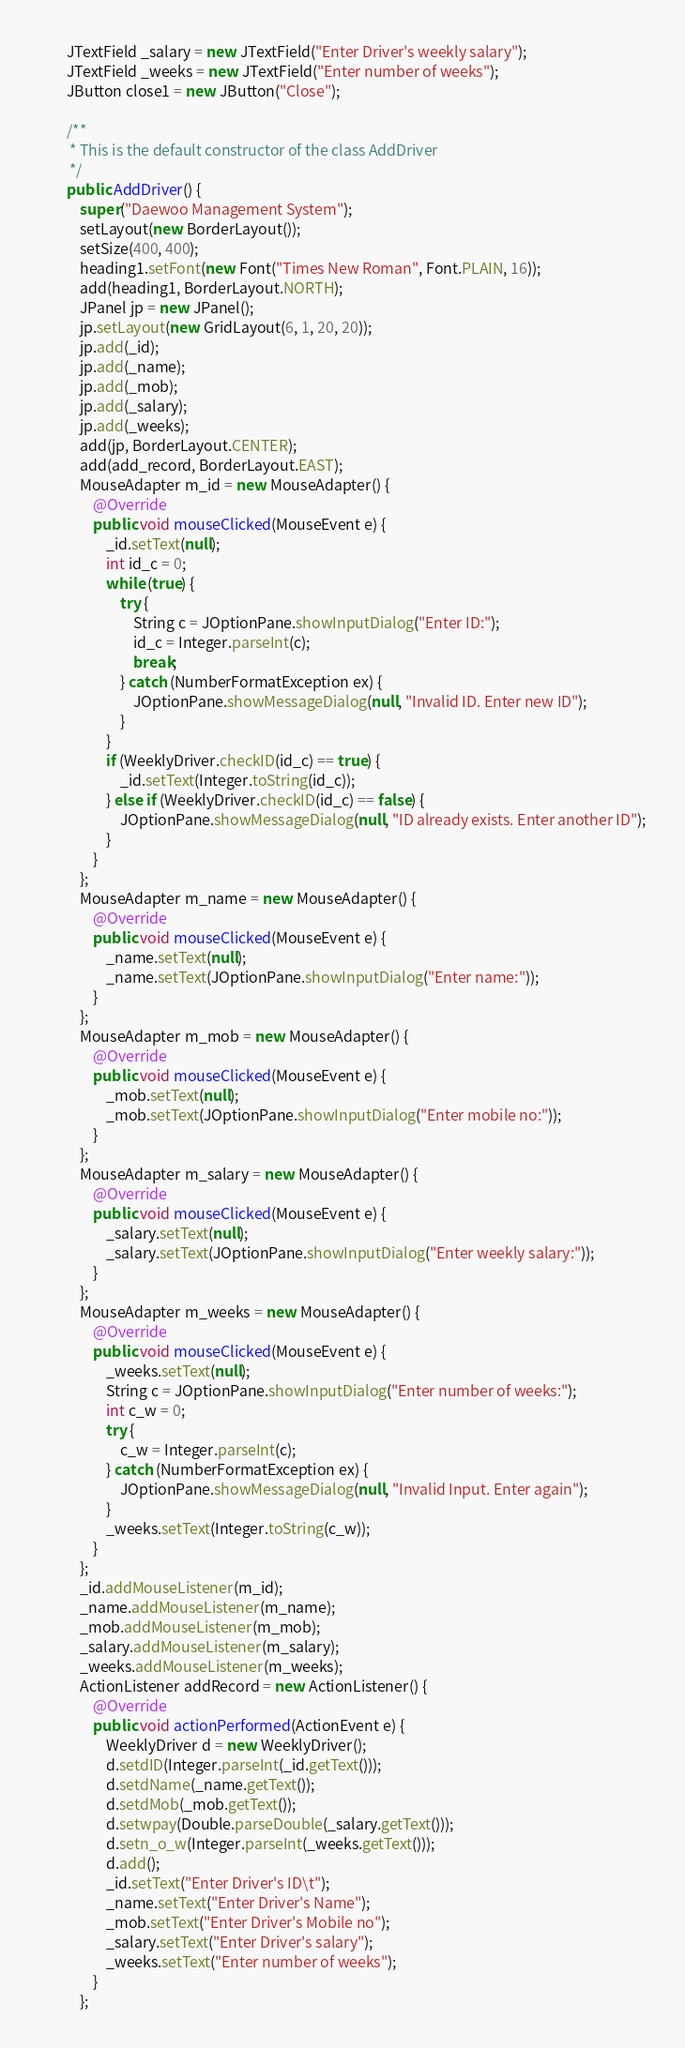<code> <loc_0><loc_0><loc_500><loc_500><_Java_>        JTextField _salary = new JTextField("Enter Driver's weekly salary");
        JTextField _weeks = new JTextField("Enter number of weeks");
        JButton close1 = new JButton("Close");

        /**
         * This is the default constructor of the class AddDriver
         */
        public AddDriver() {
            super("Daewoo Management System");
            setLayout(new BorderLayout());
            setSize(400, 400);
            heading1.setFont(new Font("Times New Roman", Font.PLAIN, 16));
            add(heading1, BorderLayout.NORTH);
            JPanel jp = new JPanel();
            jp.setLayout(new GridLayout(6, 1, 20, 20));
            jp.add(_id);
            jp.add(_name);
            jp.add(_mob);
            jp.add(_salary);
            jp.add(_weeks);
            add(jp, BorderLayout.CENTER);
            add(add_record, BorderLayout.EAST);
            MouseAdapter m_id = new MouseAdapter() {
                @Override
                public void mouseClicked(MouseEvent e) {
                    _id.setText(null);
                    int id_c = 0;
                    while (true) {
                        try {
                            String c = JOptionPane.showInputDialog("Enter ID:");
                            id_c = Integer.parseInt(c);
                            break;
                        } catch (NumberFormatException ex) {
                            JOptionPane.showMessageDialog(null, "Invalid ID. Enter new ID");
                        }
                    }
                    if (WeeklyDriver.checkID(id_c) == true) {
                        _id.setText(Integer.toString(id_c));
                    } else if (WeeklyDriver.checkID(id_c) == false) {
                        JOptionPane.showMessageDialog(null, "ID already exists. Enter another ID");
                    }
                }
            };
            MouseAdapter m_name = new MouseAdapter() {
                @Override
                public void mouseClicked(MouseEvent e) {
                    _name.setText(null);
                    _name.setText(JOptionPane.showInputDialog("Enter name:"));
                }
            };
            MouseAdapter m_mob = new MouseAdapter() {
                @Override
                public void mouseClicked(MouseEvent e) {
                    _mob.setText(null);
                    _mob.setText(JOptionPane.showInputDialog("Enter mobile no:"));
                }
            };
            MouseAdapter m_salary = new MouseAdapter() {
                @Override
                public void mouseClicked(MouseEvent e) {
                    _salary.setText(null);
                    _salary.setText(JOptionPane.showInputDialog("Enter weekly salary:"));
                }
            };
            MouseAdapter m_weeks = new MouseAdapter() {
                @Override
                public void mouseClicked(MouseEvent e) {
                    _weeks.setText(null);
                    String c = JOptionPane.showInputDialog("Enter number of weeks:");
                    int c_w = 0;
                    try {
                        c_w = Integer.parseInt(c);
                    } catch (NumberFormatException ex) {
                        JOptionPane.showMessageDialog(null, "Invalid Input. Enter again");
                    }
                    _weeks.setText(Integer.toString(c_w));
                }
            };
            _id.addMouseListener(m_id);
            _name.addMouseListener(m_name);
            _mob.addMouseListener(m_mob);
            _salary.addMouseListener(m_salary);
            _weeks.addMouseListener(m_weeks);
            ActionListener addRecord = new ActionListener() {
                @Override
                public void actionPerformed(ActionEvent e) {
                    WeeklyDriver d = new WeeklyDriver();
                    d.setdID(Integer.parseInt(_id.getText()));
                    d.setdName(_name.getText());
                    d.setdMob(_mob.getText());
                    d.setwpay(Double.parseDouble(_salary.getText()));
                    d.setn_o_w(Integer.parseInt(_weeks.getText()));
                    d.add();
                    _id.setText("Enter Driver's ID\t");
                    _name.setText("Enter Driver's Name");
                    _mob.setText("Enter Driver's Mobile no");
                    _salary.setText("Enter Driver's salary");
                    _weeks.setText("Enter number of weeks");
                }
            };</code> 